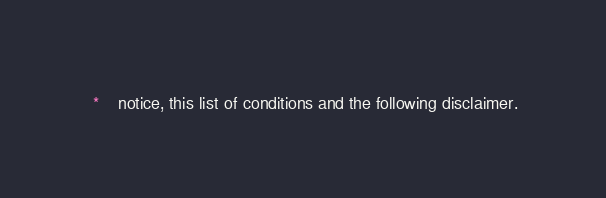Convert code to text. <code><loc_0><loc_0><loc_500><loc_500><_C_> *    notice, this list of conditions and the following disclaimer.</code> 